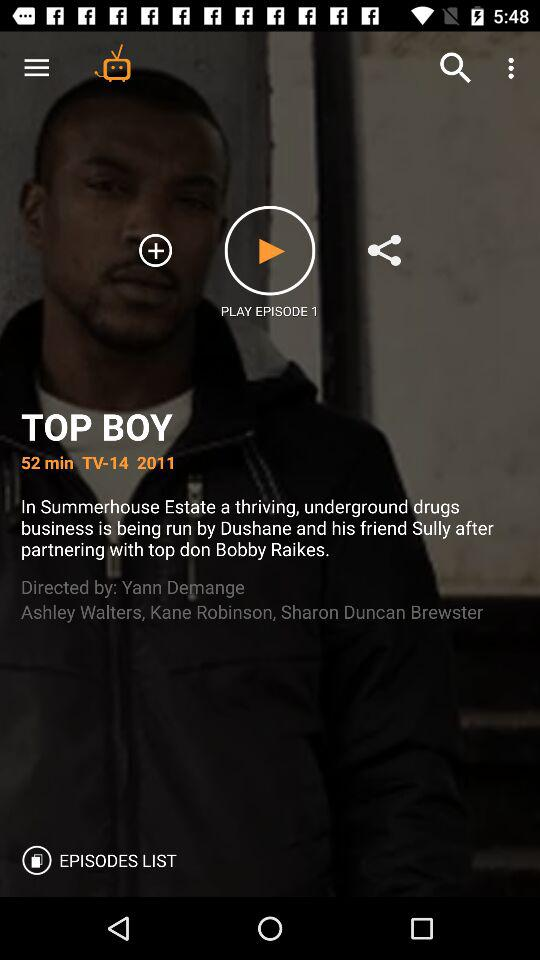What is the title of the show? The title of the show is "TOP BOY". 